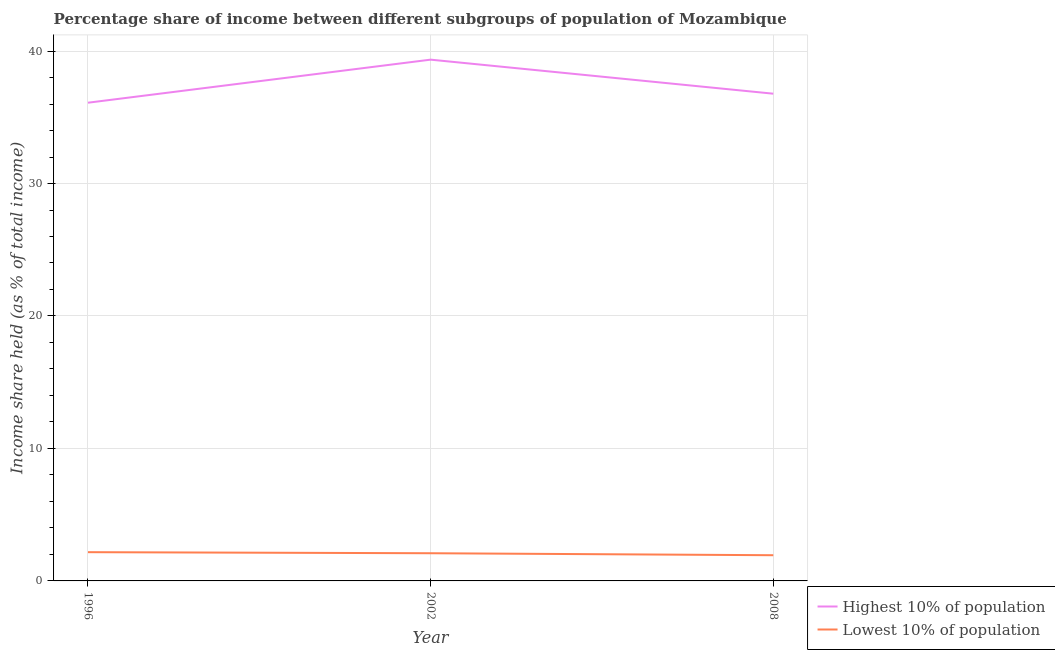How many different coloured lines are there?
Ensure brevity in your answer.  2. Does the line corresponding to income share held by highest 10% of the population intersect with the line corresponding to income share held by lowest 10% of the population?
Offer a terse response. No. Is the number of lines equal to the number of legend labels?
Provide a succinct answer. Yes. What is the income share held by highest 10% of the population in 2002?
Ensure brevity in your answer.  39.35. Across all years, what is the maximum income share held by highest 10% of the population?
Your answer should be compact. 39.35. Across all years, what is the minimum income share held by highest 10% of the population?
Offer a terse response. 36.1. In which year was the income share held by highest 10% of the population minimum?
Your answer should be very brief. 1996. What is the total income share held by lowest 10% of the population in the graph?
Ensure brevity in your answer.  6.2. What is the difference between the income share held by lowest 10% of the population in 1996 and that in 2008?
Your answer should be compact. 0.23. What is the difference between the income share held by highest 10% of the population in 1996 and the income share held by lowest 10% of the population in 2002?
Ensure brevity in your answer.  34.01. What is the average income share held by lowest 10% of the population per year?
Keep it short and to the point. 2.07. In the year 1996, what is the difference between the income share held by lowest 10% of the population and income share held by highest 10% of the population?
Your answer should be compact. -33.93. In how many years, is the income share held by lowest 10% of the population greater than 14 %?
Your answer should be compact. 0. What is the ratio of the income share held by lowest 10% of the population in 1996 to that in 2002?
Give a very brief answer. 1.04. Is the difference between the income share held by lowest 10% of the population in 1996 and 2008 greater than the difference between the income share held by highest 10% of the population in 1996 and 2008?
Your answer should be compact. Yes. What is the difference between the highest and the second highest income share held by lowest 10% of the population?
Your response must be concise. 0.08. What is the difference between the highest and the lowest income share held by lowest 10% of the population?
Offer a terse response. 0.23. In how many years, is the income share held by highest 10% of the population greater than the average income share held by highest 10% of the population taken over all years?
Your answer should be very brief. 1. Is the sum of the income share held by lowest 10% of the population in 1996 and 2008 greater than the maximum income share held by highest 10% of the population across all years?
Your answer should be very brief. No. Is the income share held by lowest 10% of the population strictly greater than the income share held by highest 10% of the population over the years?
Provide a short and direct response. No. Is the income share held by lowest 10% of the population strictly less than the income share held by highest 10% of the population over the years?
Give a very brief answer. Yes. How many years are there in the graph?
Offer a very short reply. 3. What is the difference between two consecutive major ticks on the Y-axis?
Offer a terse response. 10. How many legend labels are there?
Offer a very short reply. 2. How are the legend labels stacked?
Offer a terse response. Vertical. What is the title of the graph?
Your response must be concise. Percentage share of income between different subgroups of population of Mozambique. Does "Tetanus" appear as one of the legend labels in the graph?
Ensure brevity in your answer.  No. What is the label or title of the Y-axis?
Give a very brief answer. Income share held (as % of total income). What is the Income share held (as % of total income) of Highest 10% of population in 1996?
Your answer should be very brief. 36.1. What is the Income share held (as % of total income) of Lowest 10% of population in 1996?
Your answer should be compact. 2.17. What is the Income share held (as % of total income) of Highest 10% of population in 2002?
Your response must be concise. 39.35. What is the Income share held (as % of total income) of Lowest 10% of population in 2002?
Provide a succinct answer. 2.09. What is the Income share held (as % of total income) in Highest 10% of population in 2008?
Provide a succinct answer. 36.78. What is the Income share held (as % of total income) of Lowest 10% of population in 2008?
Offer a terse response. 1.94. Across all years, what is the maximum Income share held (as % of total income) of Highest 10% of population?
Your response must be concise. 39.35. Across all years, what is the maximum Income share held (as % of total income) of Lowest 10% of population?
Your answer should be very brief. 2.17. Across all years, what is the minimum Income share held (as % of total income) of Highest 10% of population?
Offer a terse response. 36.1. Across all years, what is the minimum Income share held (as % of total income) of Lowest 10% of population?
Give a very brief answer. 1.94. What is the total Income share held (as % of total income) in Highest 10% of population in the graph?
Ensure brevity in your answer.  112.23. What is the difference between the Income share held (as % of total income) of Highest 10% of population in 1996 and that in 2002?
Provide a short and direct response. -3.25. What is the difference between the Income share held (as % of total income) in Highest 10% of population in 1996 and that in 2008?
Ensure brevity in your answer.  -0.68. What is the difference between the Income share held (as % of total income) in Lowest 10% of population in 1996 and that in 2008?
Keep it short and to the point. 0.23. What is the difference between the Income share held (as % of total income) of Highest 10% of population in 2002 and that in 2008?
Provide a succinct answer. 2.57. What is the difference between the Income share held (as % of total income) of Highest 10% of population in 1996 and the Income share held (as % of total income) of Lowest 10% of population in 2002?
Offer a very short reply. 34.01. What is the difference between the Income share held (as % of total income) in Highest 10% of population in 1996 and the Income share held (as % of total income) in Lowest 10% of population in 2008?
Offer a terse response. 34.16. What is the difference between the Income share held (as % of total income) in Highest 10% of population in 2002 and the Income share held (as % of total income) in Lowest 10% of population in 2008?
Give a very brief answer. 37.41. What is the average Income share held (as % of total income) of Highest 10% of population per year?
Make the answer very short. 37.41. What is the average Income share held (as % of total income) of Lowest 10% of population per year?
Provide a succinct answer. 2.07. In the year 1996, what is the difference between the Income share held (as % of total income) in Highest 10% of population and Income share held (as % of total income) in Lowest 10% of population?
Your answer should be very brief. 33.93. In the year 2002, what is the difference between the Income share held (as % of total income) in Highest 10% of population and Income share held (as % of total income) in Lowest 10% of population?
Provide a succinct answer. 37.26. In the year 2008, what is the difference between the Income share held (as % of total income) in Highest 10% of population and Income share held (as % of total income) in Lowest 10% of population?
Your response must be concise. 34.84. What is the ratio of the Income share held (as % of total income) of Highest 10% of population in 1996 to that in 2002?
Make the answer very short. 0.92. What is the ratio of the Income share held (as % of total income) of Lowest 10% of population in 1996 to that in 2002?
Provide a short and direct response. 1.04. What is the ratio of the Income share held (as % of total income) of Highest 10% of population in 1996 to that in 2008?
Offer a terse response. 0.98. What is the ratio of the Income share held (as % of total income) of Lowest 10% of population in 1996 to that in 2008?
Provide a short and direct response. 1.12. What is the ratio of the Income share held (as % of total income) of Highest 10% of population in 2002 to that in 2008?
Provide a short and direct response. 1.07. What is the ratio of the Income share held (as % of total income) of Lowest 10% of population in 2002 to that in 2008?
Offer a terse response. 1.08. What is the difference between the highest and the second highest Income share held (as % of total income) in Highest 10% of population?
Ensure brevity in your answer.  2.57. What is the difference between the highest and the lowest Income share held (as % of total income) in Lowest 10% of population?
Provide a succinct answer. 0.23. 